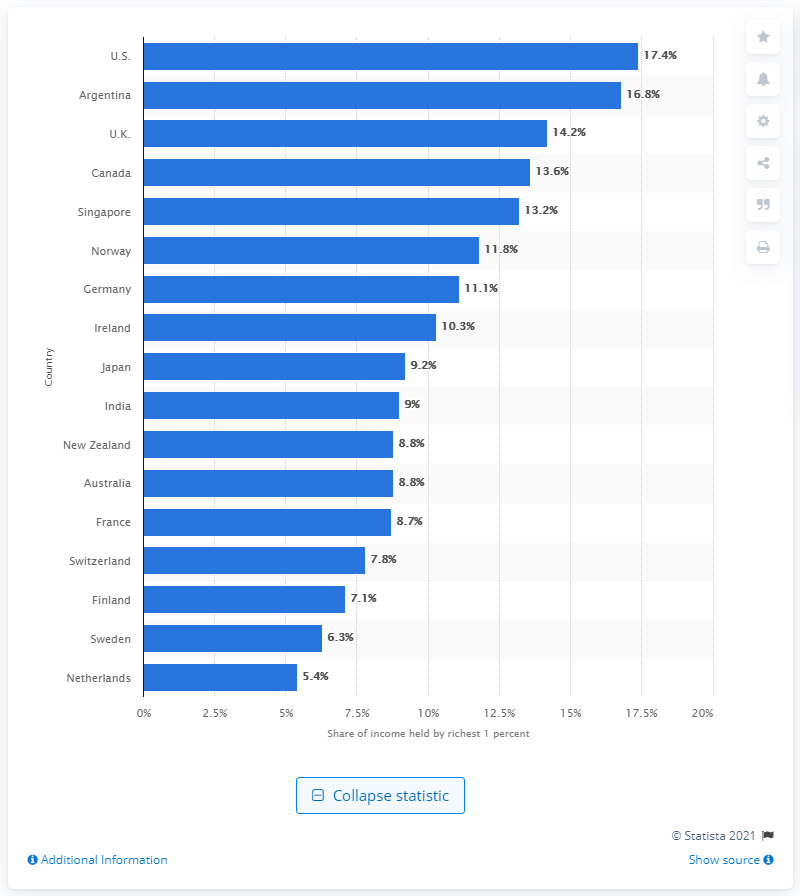Highlight a few significant elements in this photo. In 2005, the richest top percent of U.S. citizens earned an income of 17.4%. 